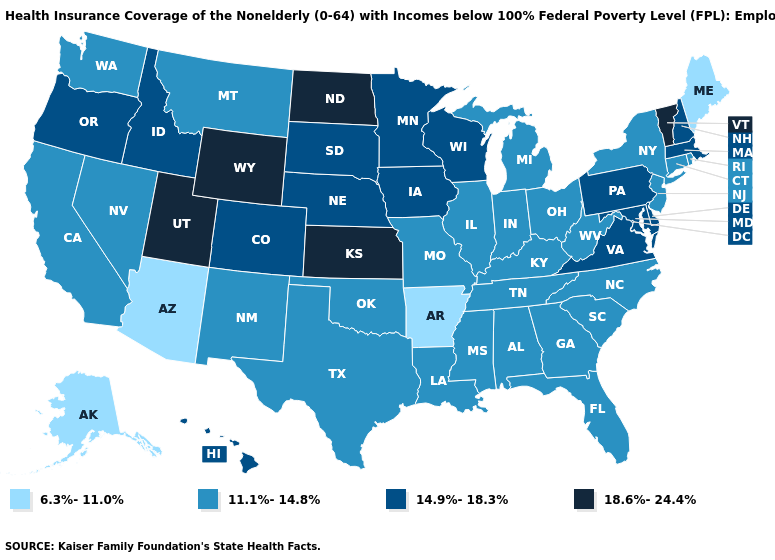Name the states that have a value in the range 11.1%-14.8%?
Short answer required. Alabama, California, Connecticut, Florida, Georgia, Illinois, Indiana, Kentucky, Louisiana, Michigan, Mississippi, Missouri, Montana, Nevada, New Jersey, New Mexico, New York, North Carolina, Ohio, Oklahoma, Rhode Island, South Carolina, Tennessee, Texas, Washington, West Virginia. Name the states that have a value in the range 18.6%-24.4%?
Be succinct. Kansas, North Dakota, Utah, Vermont, Wyoming. What is the lowest value in the USA?
Be succinct. 6.3%-11.0%. Among the states that border Nevada , does Utah have the lowest value?
Quick response, please. No. What is the value of Arkansas?
Answer briefly. 6.3%-11.0%. Is the legend a continuous bar?
Quick response, please. No. What is the value of Tennessee?
Keep it brief. 11.1%-14.8%. What is the lowest value in the USA?
Quick response, please. 6.3%-11.0%. What is the lowest value in the USA?
Be succinct. 6.3%-11.0%. Among the states that border Iowa , which have the lowest value?
Concise answer only. Illinois, Missouri. What is the highest value in the South ?
Quick response, please. 14.9%-18.3%. Name the states that have a value in the range 6.3%-11.0%?
Quick response, please. Alaska, Arizona, Arkansas, Maine. Does Ohio have the highest value in the MidWest?
Give a very brief answer. No. Name the states that have a value in the range 18.6%-24.4%?
Concise answer only. Kansas, North Dakota, Utah, Vermont, Wyoming. What is the highest value in states that border Utah?
Give a very brief answer. 18.6%-24.4%. 